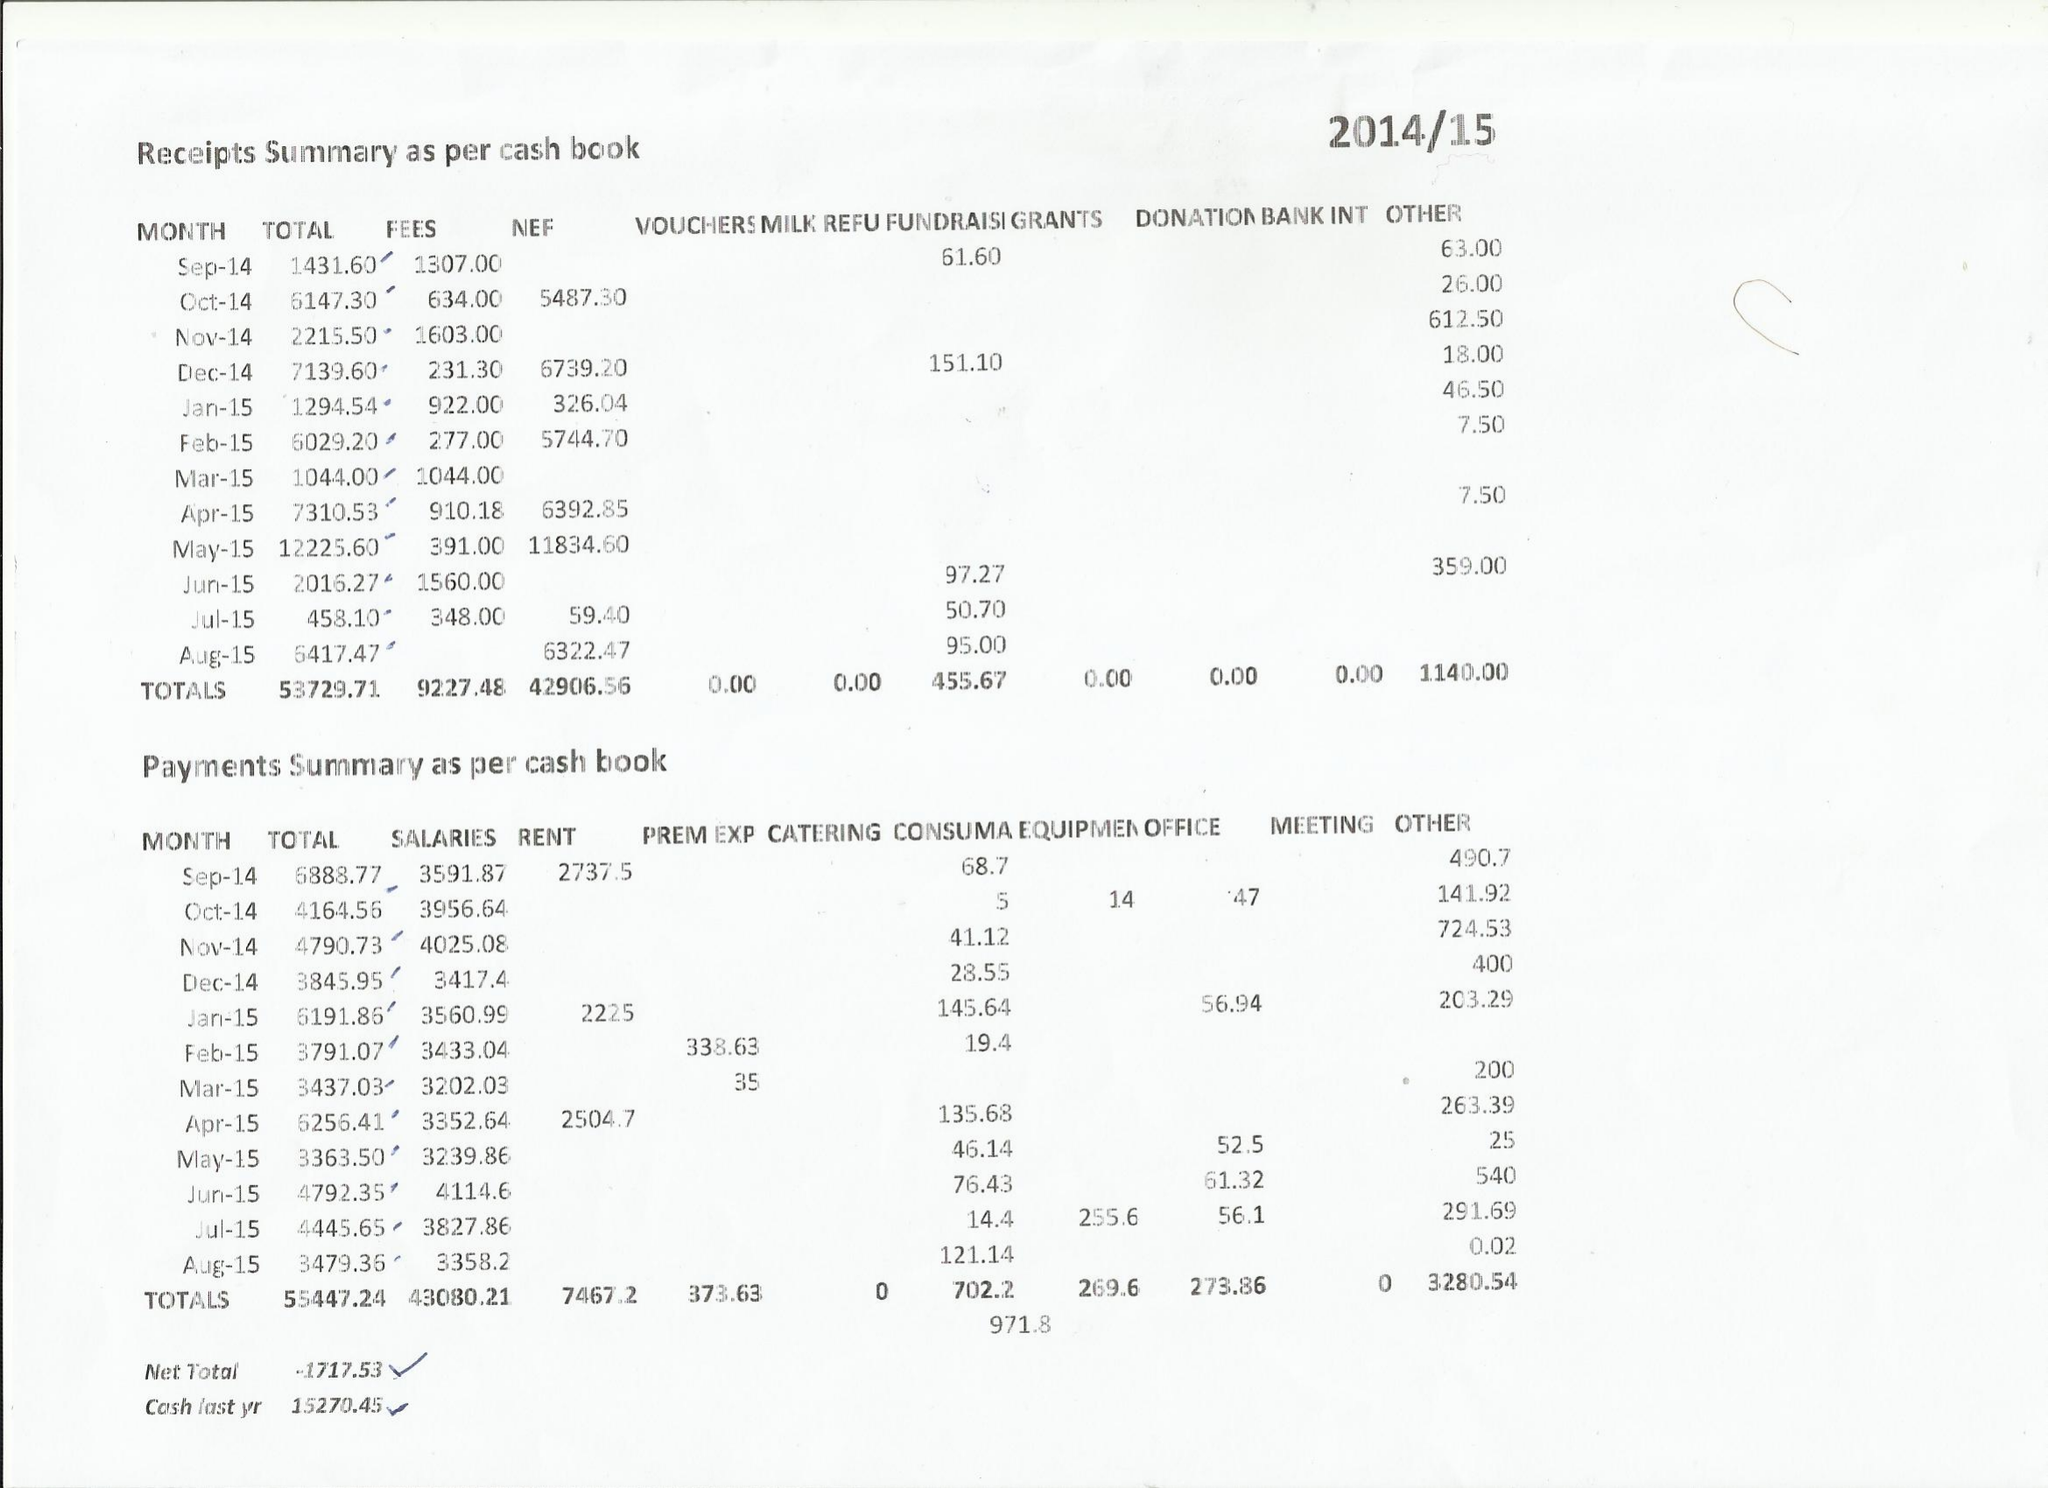What is the value for the charity_name?
Answer the question using a single word or phrase. Willow Rise Pre-School 